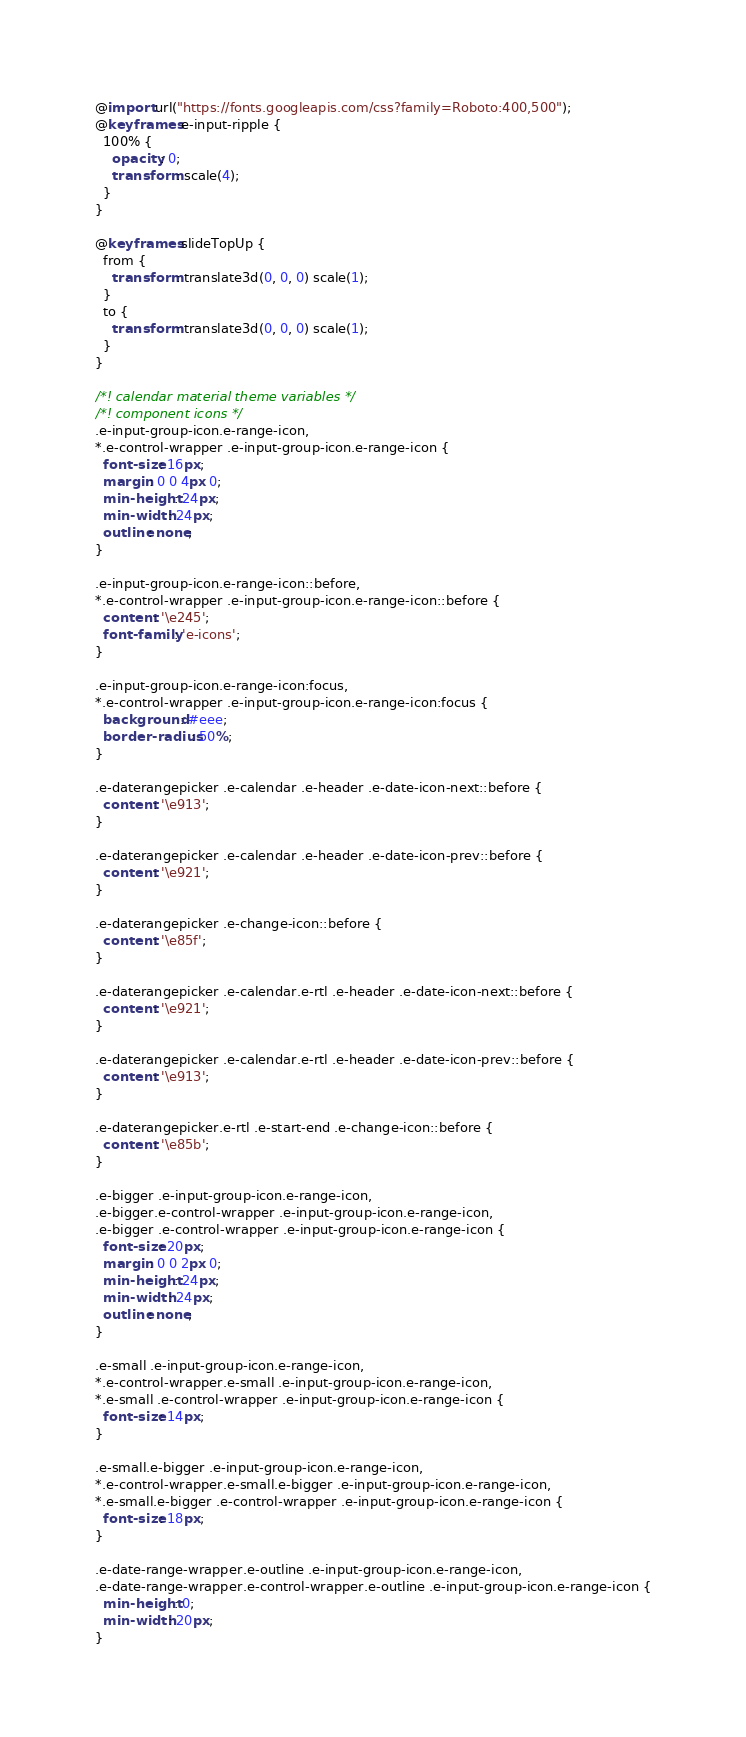<code> <loc_0><loc_0><loc_500><loc_500><_CSS_>@import url("https://fonts.googleapis.com/css?family=Roboto:400,500");
@keyframes e-input-ripple {
  100% {
    opacity: 0;
    transform: scale(4);
  }
}

@keyframes slideTopUp {
  from {
    transform: translate3d(0, 0, 0) scale(1);
  }
  to {
    transform: translate3d(0, 0, 0) scale(1);
  }
}

/*! calendar material theme variables */
/*! component icons */
.e-input-group-icon.e-range-icon,
*.e-control-wrapper .e-input-group-icon.e-range-icon {
  font-size: 16px;
  margin: 0 0 4px 0;
  min-height: 24px;
  min-width: 24px;
  outline: none;
}

.e-input-group-icon.e-range-icon::before,
*.e-control-wrapper .e-input-group-icon.e-range-icon::before {
  content: '\e245';
  font-family: 'e-icons';
}

.e-input-group-icon.e-range-icon:focus,
*.e-control-wrapper .e-input-group-icon.e-range-icon:focus {
  background: #eee;
  border-radius: 50%;
}

.e-daterangepicker .e-calendar .e-header .e-date-icon-next::before {
  content: '\e913';
}

.e-daterangepicker .e-calendar .e-header .e-date-icon-prev::before {
  content: '\e921';
}

.e-daterangepicker .e-change-icon::before {
  content: '\e85f';
}

.e-daterangepicker .e-calendar.e-rtl .e-header .e-date-icon-next::before {
  content: '\e921';
}

.e-daterangepicker .e-calendar.e-rtl .e-header .e-date-icon-prev::before {
  content: '\e913';
}

.e-daterangepicker.e-rtl .e-start-end .e-change-icon::before {
  content: '\e85b';
}

.e-bigger .e-input-group-icon.e-range-icon,
.e-bigger.e-control-wrapper .e-input-group-icon.e-range-icon,
.e-bigger .e-control-wrapper .e-input-group-icon.e-range-icon {
  font-size: 20px;
  margin: 0 0 2px 0;
  min-height: 24px;
  min-width: 24px;
  outline: none;
}

.e-small .e-input-group-icon.e-range-icon,
*.e-control-wrapper.e-small .e-input-group-icon.e-range-icon,
*.e-small .e-control-wrapper .e-input-group-icon.e-range-icon {
  font-size: 14px;
}

.e-small.e-bigger .e-input-group-icon.e-range-icon,
*.e-control-wrapper.e-small.e-bigger .e-input-group-icon.e-range-icon,
*.e-small.e-bigger .e-control-wrapper .e-input-group-icon.e-range-icon {
  font-size: 18px;
}

.e-date-range-wrapper.e-outline .e-input-group-icon.e-range-icon,
.e-date-range-wrapper.e-control-wrapper.e-outline .e-input-group-icon.e-range-icon {
  min-height: 0;
  min-width: 20px;
}
</code> 